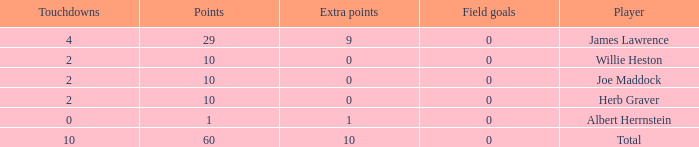Give me the full table as a dictionary. {'header': ['Touchdowns', 'Points', 'Extra points', 'Field goals', 'Player'], 'rows': [['4', '29', '9', '0', 'James Lawrence'], ['2', '10', '0', '0', 'Willie Heston'], ['2', '10', '0', '0', 'Joe Maddock'], ['2', '10', '0', '0', 'Herb Graver'], ['0', '1', '1', '0', 'Albert Herrnstein'], ['10', '60', '10', '0', 'Total']]} What is the average number of field goals for players with more than 60 points? None. 